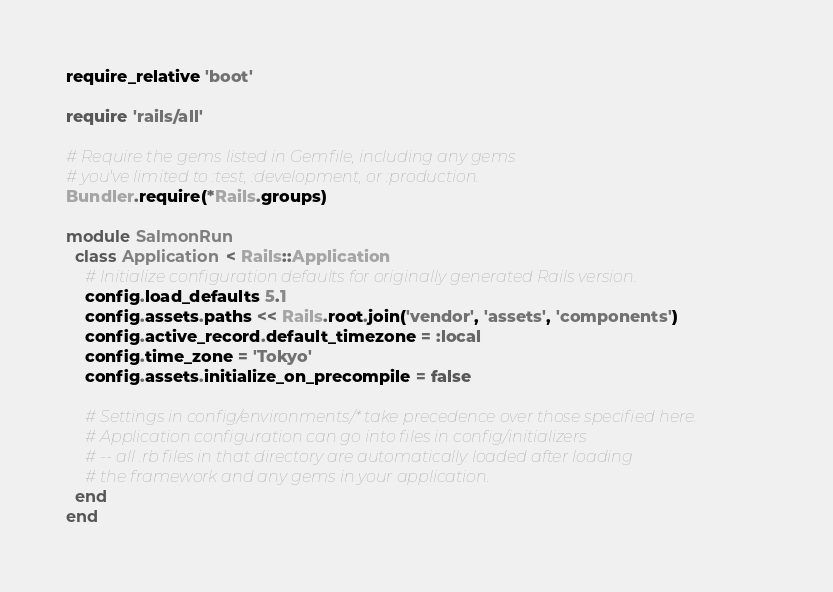<code> <loc_0><loc_0><loc_500><loc_500><_Ruby_>require_relative 'boot'

require 'rails/all'

# Require the gems listed in Gemfile, including any gems
# you've limited to :test, :development, or :production.
Bundler.require(*Rails.groups)

module SalmonRun
  class Application < Rails::Application
    # Initialize configuration defaults for originally generated Rails version.
    config.load_defaults 5.1
    config.assets.paths << Rails.root.join('vendor', 'assets', 'components')
    config.active_record.default_timezone = :local
    config.time_zone = 'Tokyo'
    config.assets.initialize_on_precompile = false

    # Settings in config/environments/* take precedence over those specified here.
    # Application configuration can go into files in config/initializers
    # -- all .rb files in that directory are automatically loaded after loading
    # the framework and any gems in your application.
  end
end
</code> 